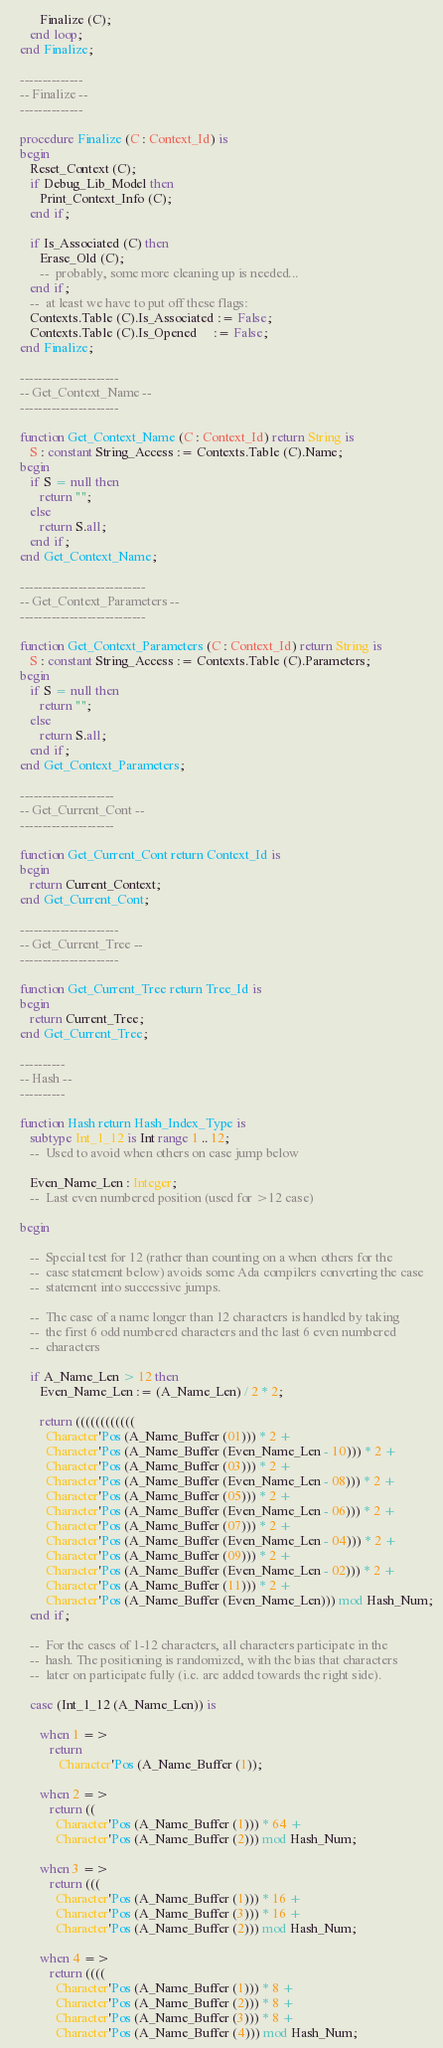<code> <loc_0><loc_0><loc_500><loc_500><_Ada_>         Finalize (C);
      end loop;
   end Finalize;

   --------------
   -- Finalize --
   --------------

   procedure Finalize (C : Context_Id) is
   begin
      Reset_Context (C);
      if Debug_Lib_Model then
         Print_Context_Info (C);
      end if;

      if Is_Associated (C) then
         Erase_Old (C);
         --  probably, some more cleaning up is needed...
      end if;
      --  at least we have to put off these flags:
      Contexts.Table (C).Is_Associated := False;
      Contexts.Table (C).Is_Opened     := False;
   end Finalize;

   ----------------------
   -- Get_Context_Name --
   ----------------------

   function Get_Context_Name (C : Context_Id) return String is
      S : constant String_Access := Contexts.Table (C).Name;
   begin
      if S = null then
         return "";
      else
         return S.all;
      end if;
   end Get_Context_Name;

   ----------------------------
   -- Get_Context_Parameters --
   ----------------------------

   function Get_Context_Parameters (C : Context_Id) return String is
      S : constant String_Access := Contexts.Table (C).Parameters;
   begin
      if S = null then
         return "";
      else
         return S.all;
      end if;
   end Get_Context_Parameters;

   ---------------------
   -- Get_Current_Cont --
   ---------------------

   function Get_Current_Cont return Context_Id is
   begin
      return Current_Context;
   end Get_Current_Cont;

   ----------------------
   -- Get_Current_Tree --
   ----------------------

   function Get_Current_Tree return Tree_Id is
   begin
      return Current_Tree;
   end Get_Current_Tree;

   ----------
   -- Hash --
   ----------

   function Hash return Hash_Index_Type is
      subtype Int_1_12 is Int range 1 .. 12;
      --  Used to avoid when others on case jump below

      Even_Name_Len : Integer;
      --  Last even numbered position (used for >12 case)

   begin

      --  Special test for 12 (rather than counting on a when others for the
      --  case statement below) avoids some Ada compilers converting the case
      --  statement into successive jumps.

      --  The case of a name longer than 12 characters is handled by taking
      --  the first 6 odd numbered characters and the last 6 even numbered
      --  characters

      if A_Name_Len > 12 then
         Even_Name_Len := (A_Name_Len) / 2 * 2;

         return ((((((((((((
           Character'Pos (A_Name_Buffer (01))) * 2 +
           Character'Pos (A_Name_Buffer (Even_Name_Len - 10))) * 2 +
           Character'Pos (A_Name_Buffer (03))) * 2 +
           Character'Pos (A_Name_Buffer (Even_Name_Len - 08))) * 2 +
           Character'Pos (A_Name_Buffer (05))) * 2 +
           Character'Pos (A_Name_Buffer (Even_Name_Len - 06))) * 2 +
           Character'Pos (A_Name_Buffer (07))) * 2 +
           Character'Pos (A_Name_Buffer (Even_Name_Len - 04))) * 2 +
           Character'Pos (A_Name_Buffer (09))) * 2 +
           Character'Pos (A_Name_Buffer (Even_Name_Len - 02))) * 2 +
           Character'Pos (A_Name_Buffer (11))) * 2 +
           Character'Pos (A_Name_Buffer (Even_Name_Len))) mod Hash_Num;
      end if;

      --  For the cases of 1-12 characters, all characters participate in the
      --  hash. The positioning is randomized, with the bias that characters
      --  later on participate fully (i.e. are added towards the right side).

      case (Int_1_12 (A_Name_Len)) is

         when 1 =>
            return
               Character'Pos (A_Name_Buffer (1));

         when 2 =>
            return ((
              Character'Pos (A_Name_Buffer (1))) * 64 +
              Character'Pos (A_Name_Buffer (2))) mod Hash_Num;

         when 3 =>
            return (((
              Character'Pos (A_Name_Buffer (1))) * 16 +
              Character'Pos (A_Name_Buffer (3))) * 16 +
              Character'Pos (A_Name_Buffer (2))) mod Hash_Num;

         when 4 =>
            return ((((
              Character'Pos (A_Name_Buffer (1))) * 8 +
              Character'Pos (A_Name_Buffer (2))) * 8 +
              Character'Pos (A_Name_Buffer (3))) * 8 +
              Character'Pos (A_Name_Buffer (4))) mod Hash_Num;
</code> 